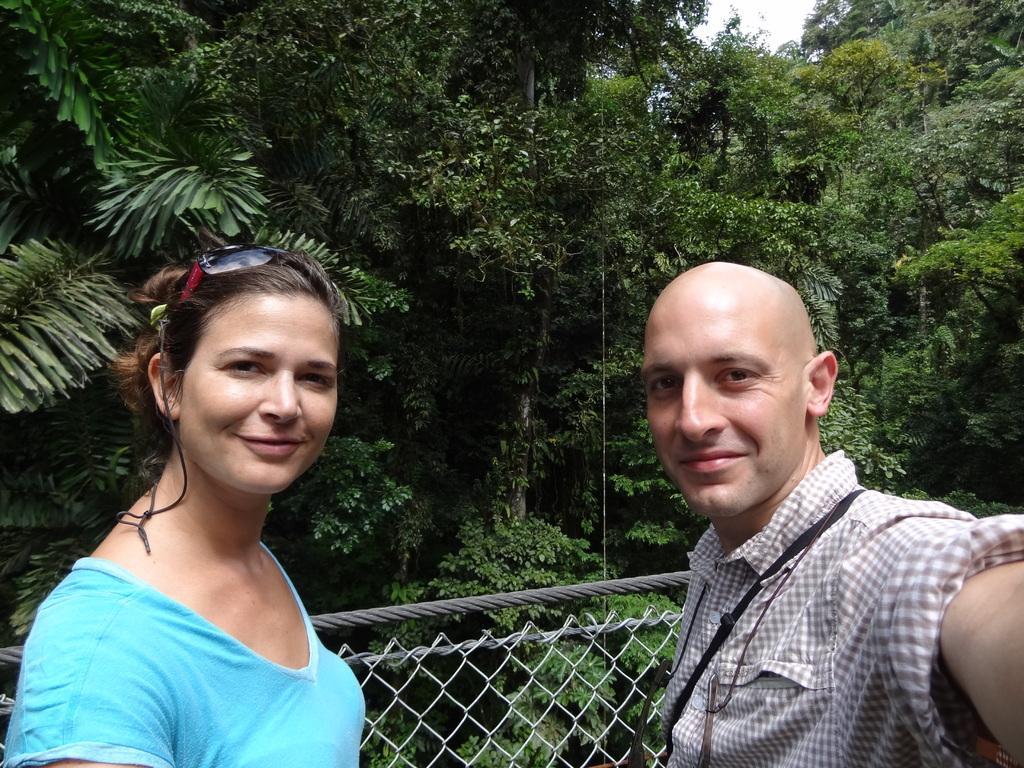Could you give a brief overview of what you see in this image? In this image I can see two persons. There is a fence, there are trees and there is sky. 